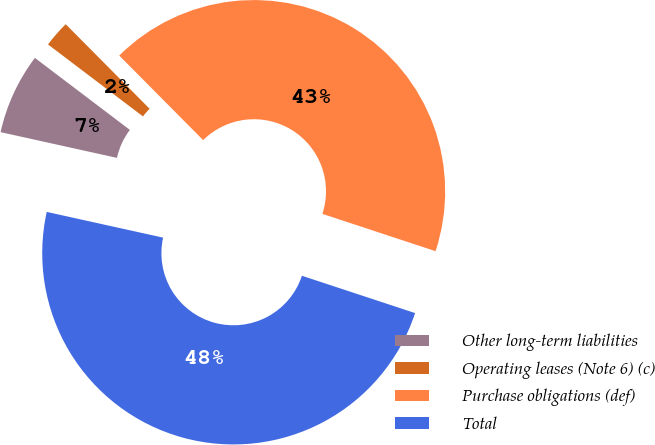Convert chart to OTSL. <chart><loc_0><loc_0><loc_500><loc_500><pie_chart><fcel>Other long-term liabilities<fcel>Operating leases (Note 6) (c)<fcel>Purchase obligations (def)<fcel>Total<nl><fcel>6.86%<fcel>2.24%<fcel>42.51%<fcel>48.4%<nl></chart> 